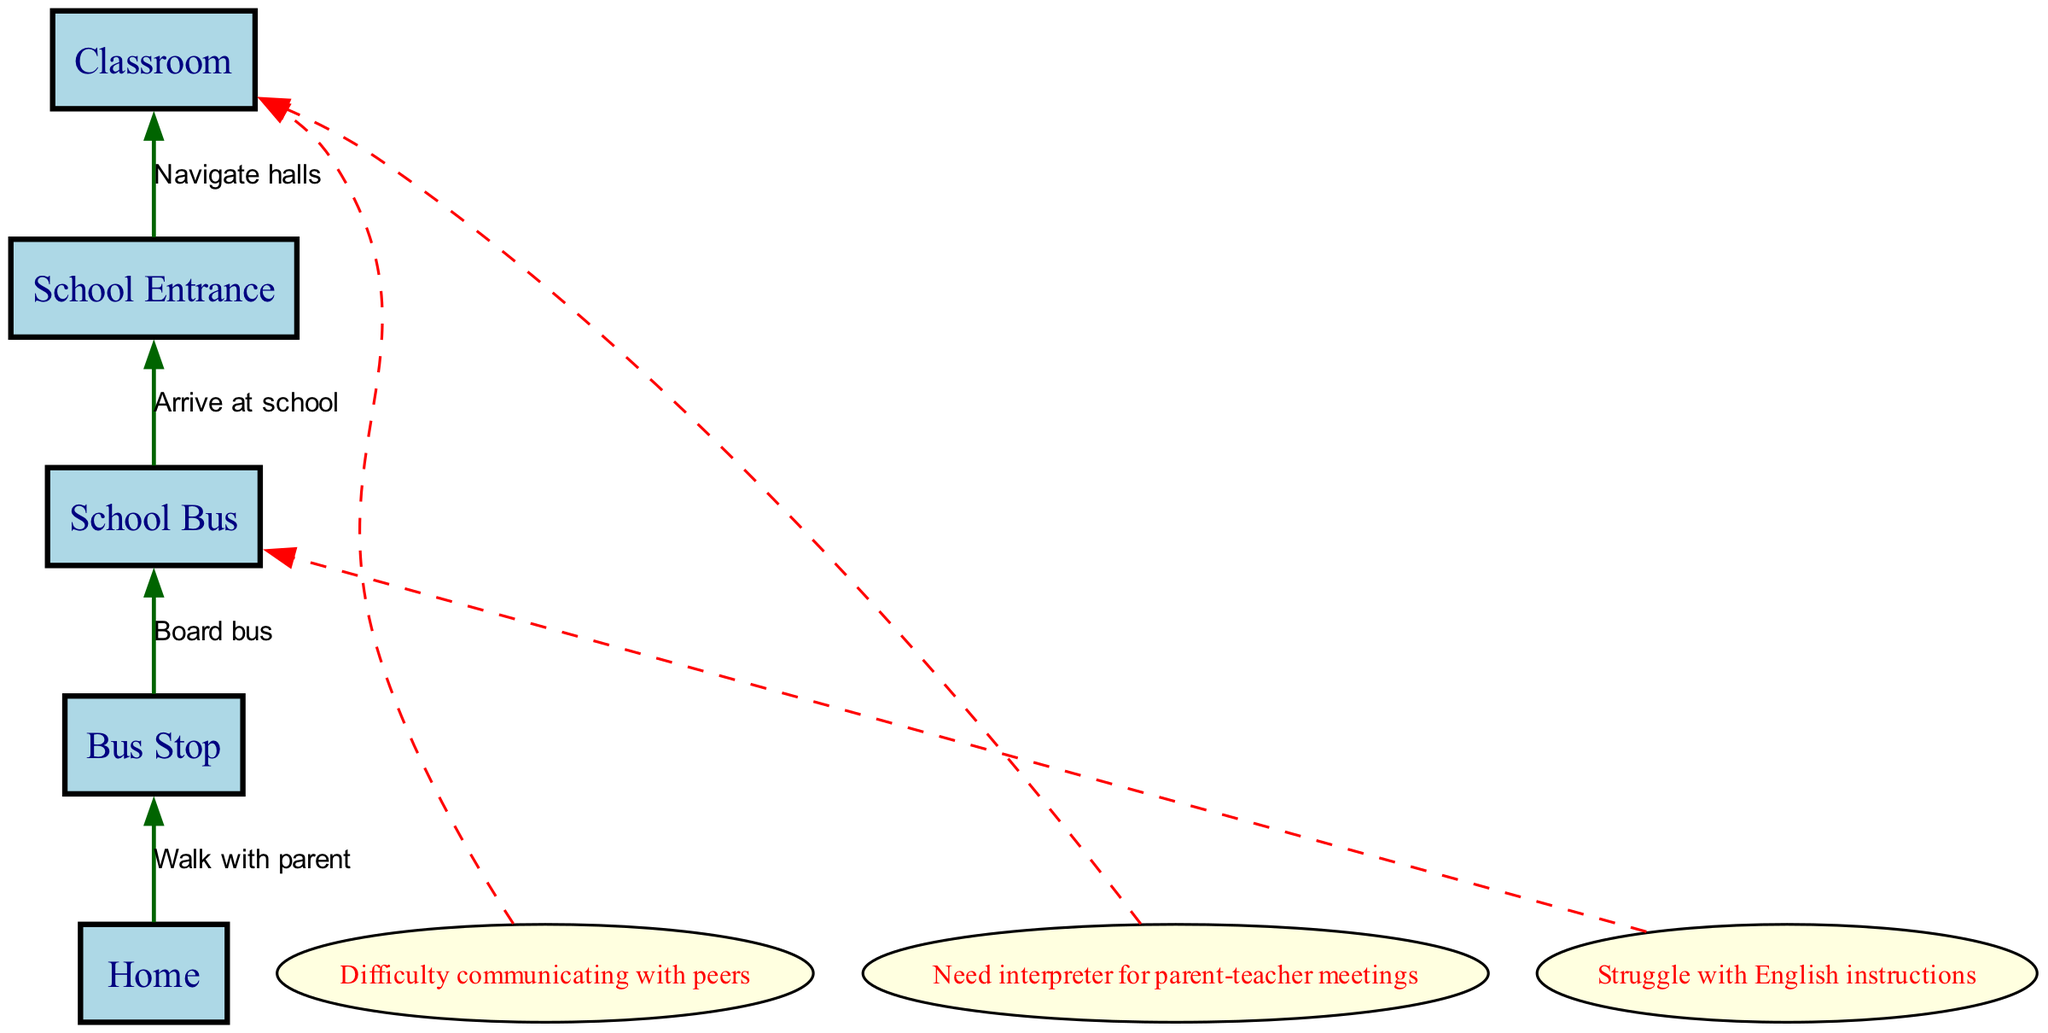1. What is the first node in the journey? The first node in the journey, according to the diagram, is "Home". It is identified as the starting point before any transitions occur.
Answer: Home 2. How do you get from the Bus Stop to the School Bus? To get from the Bus Stop to the School Bus, you need to "Board bus". This transition is indicated by the edge connecting these two nodes with the specified action.
Answer: Board bus 3. How many barriers to communication are mentioned? Three barriers to communication are mentioned in the diagram, as listed under the barriers section of the data provided.
Answer: 3 4. Which node does the barrier "Struggle with English instructions" connect to? The barrier "Struggle with English instructions" connects to the "School Bus" node. This is shown by the dashed edge in the diagram linking the barrier to the relevant node.
Answer: School Bus 5. What action occurs between the School Entrance and the Classroom? The action that occurs between the School Entrance and the Classroom is "Navigate halls". This is directly indicated by the edge connecting these two nodes in the flow chart.
Answer: Navigate halls 6. What is the last node in the journey? The last node in the journey is "Classroom". This node represents the final destination after all preceding transitions have taken place.
Answer: Classroom 7. What type of interaction is needed for parent-teacher meetings? The interaction needed for parent-teacher meetings is an "interpreter". This information is found under the barriers section and indicates a necessary resource for effective communication.
Answer: interpreter 8. How many nodes are there in total? There are five nodes in total in the diagram, each representing a stage in the child's journey from home to school.
Answer: 5 9. What is the relationship between Home and Bus Stop? The relationship between Home and Bus Stop involves the action "Walk with parent". This describes the means of transitioning from one node to the next in the child’s journey.
Answer: Walk with parent 